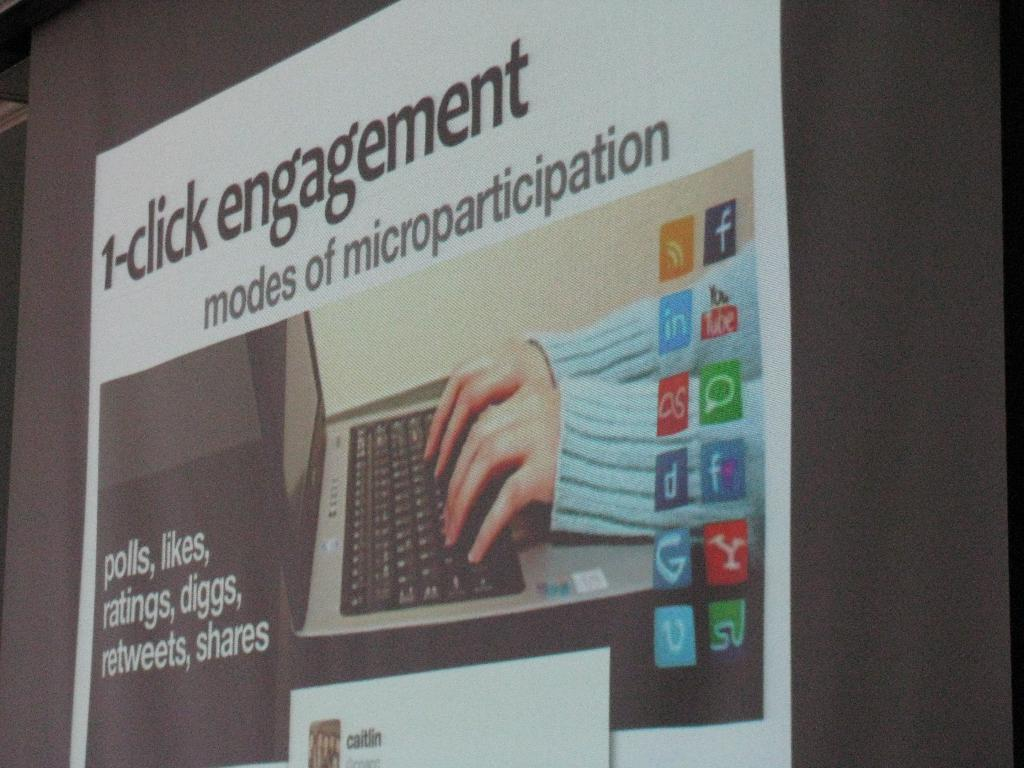<image>
Share a concise interpretation of the image provided. A close up of a bulletin board talking about 1 click engagement. 